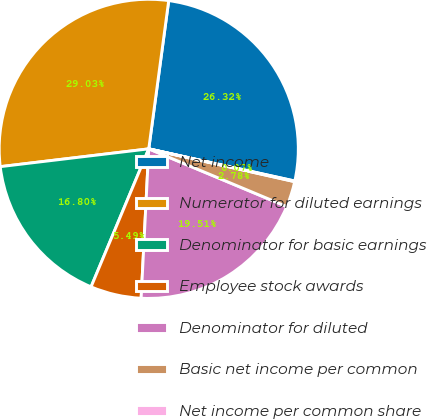Convert chart. <chart><loc_0><loc_0><loc_500><loc_500><pie_chart><fcel>Net income<fcel>Numerator for diluted earnings<fcel>Denominator for basic earnings<fcel>Employee stock awards<fcel>Denominator for diluted<fcel>Basic net income per common<fcel>Net income per common share<nl><fcel>26.32%<fcel>29.03%<fcel>16.8%<fcel>5.49%<fcel>19.51%<fcel>2.78%<fcel>0.07%<nl></chart> 